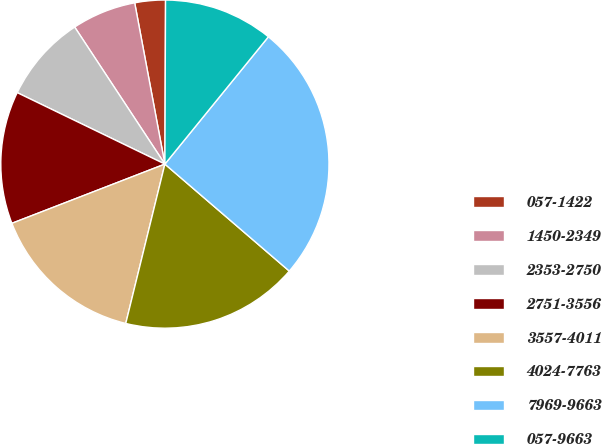<chart> <loc_0><loc_0><loc_500><loc_500><pie_chart><fcel>057-1422<fcel>1450-2349<fcel>2353-2750<fcel>2751-3556<fcel>3557-4011<fcel>4024-7763<fcel>7969-9663<fcel>057-9663<nl><fcel>3.01%<fcel>6.32%<fcel>8.56%<fcel>13.05%<fcel>15.29%<fcel>17.53%<fcel>25.44%<fcel>10.8%<nl></chart> 